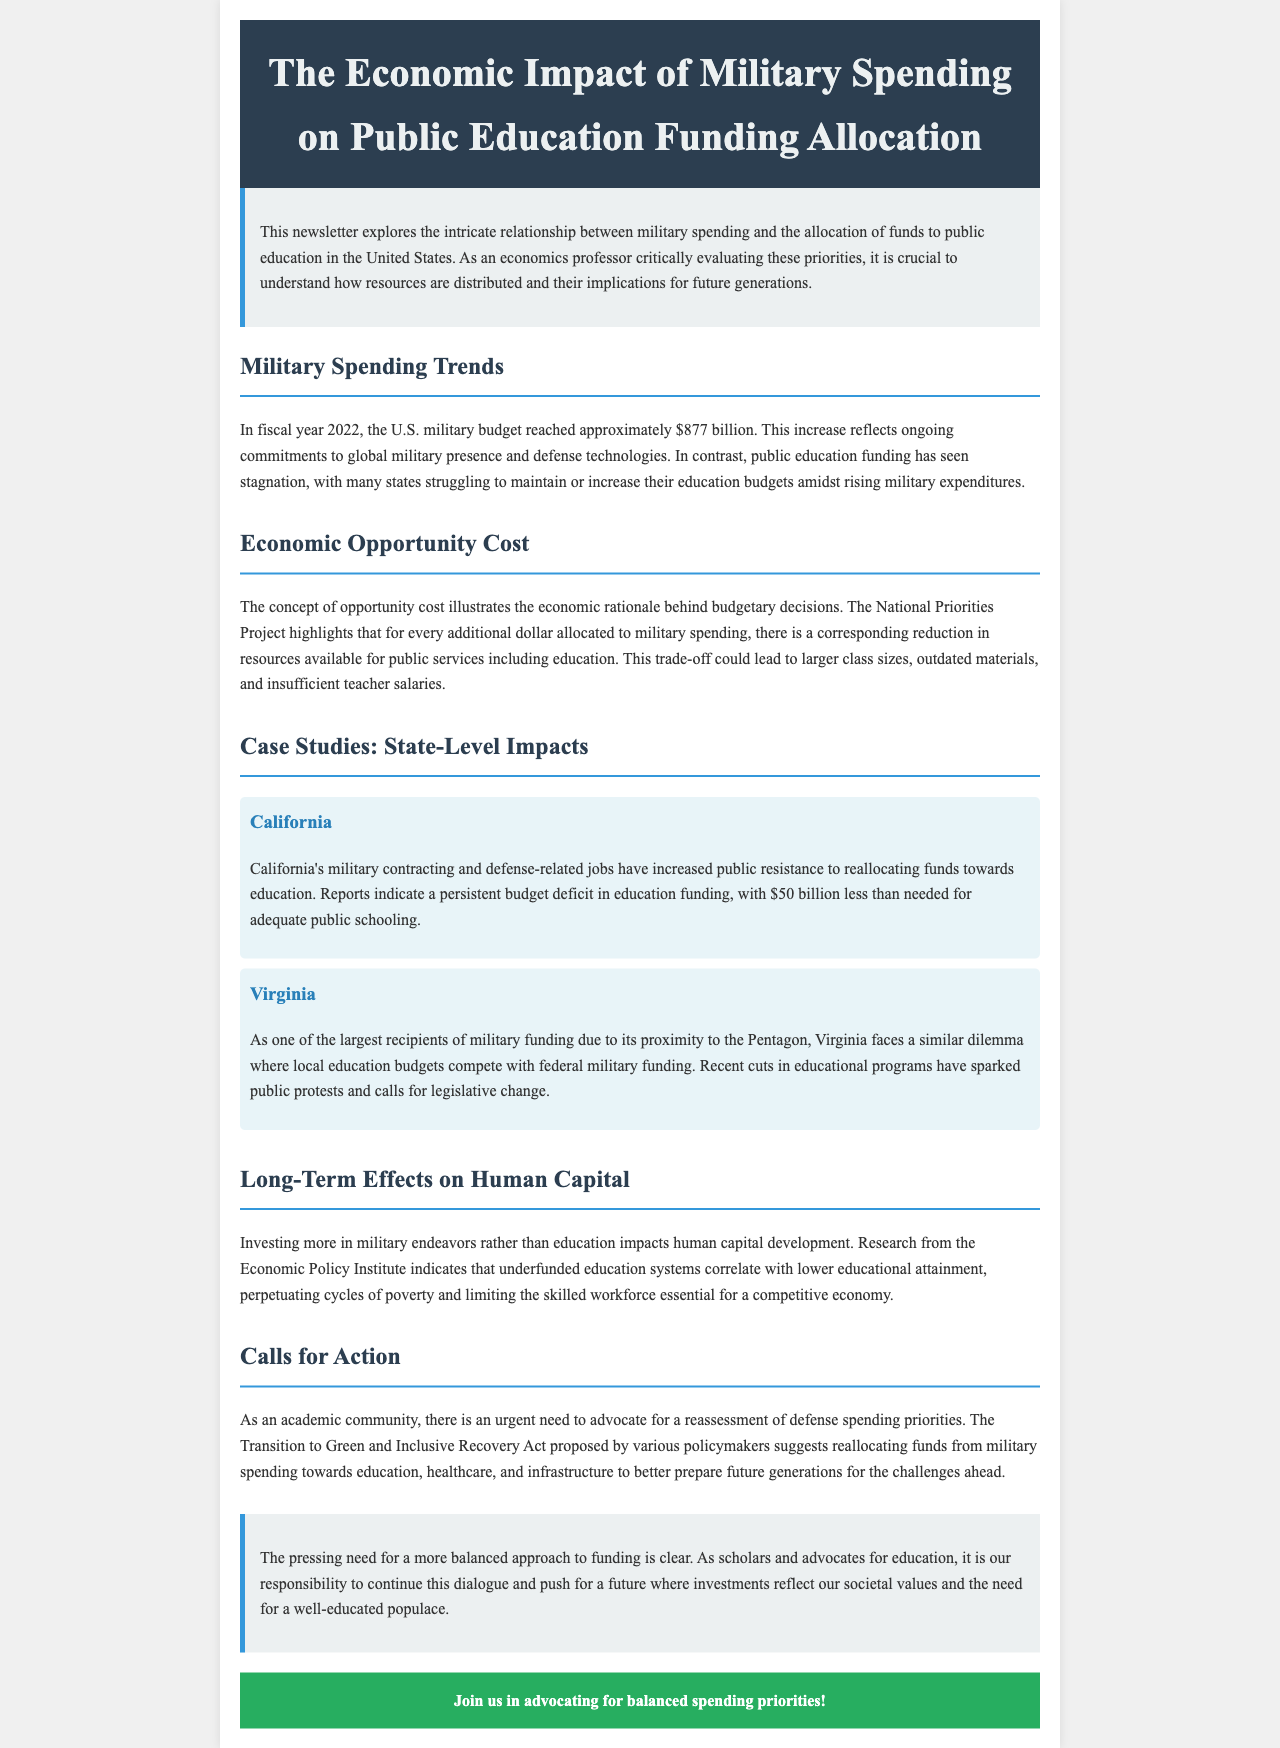What was the U.S. military budget in fiscal year 2022? The document states that in fiscal year 2022, the U.S. military budget reached approximately $877 billion.
Answer: $877 billion What is the opportunity cost in military spending? The opportunity cost refers to the corresponding reduction in resources available for public services including education when more is allocated to military spending.
Answer: Reduction in public services How much does California's education system lack for adequate schooling? According to the document, California's education funding is reported to be $50 billion less than needed for adequate public schooling.
Answer: $50 billion Which state faces a similar military funding dilemma as California? The document mentions Virginia, which as one of the largest recipients of military funding competes local education budgets with federal military funding.
Answer: Virginia What does research from the Economic Policy Institute indicate? It indicates that underfunded education systems correlate with lower educational attainment.
Answer: Lower educational attainment What action do policymakers suggest regarding military spending? The Transition to Green and Inclusive Recovery Act suggests reallocating funds from military spending towards education, healthcare, and infrastructure.
Answer: Reallocation of funds What is the main theme of the newsletter? The main theme is exploring the relationship between military spending and the allocation of funds to public education.
Answer: Relationship between military spending and education funding Who is the target audience for this newsletter? The target audience includes the academic community and advocates for education who are concerned about funding priorities.
Answer: Academic community and advocates for education 